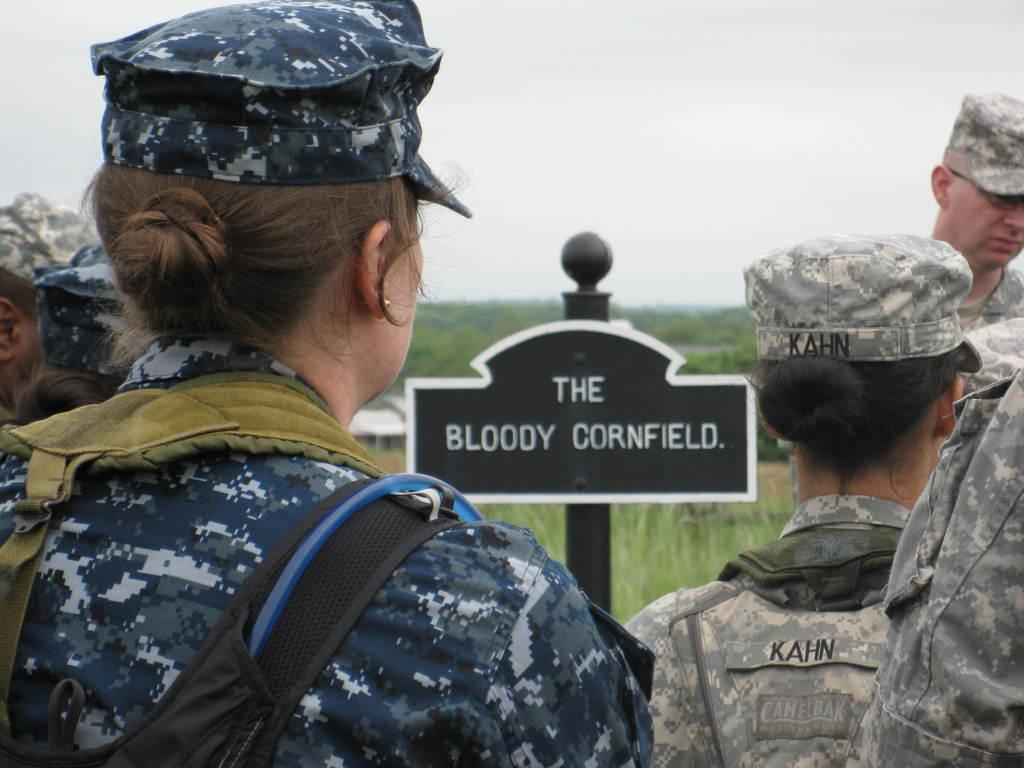Who are the people in the image? There are military officers in the image. What is on the board that is visible in the image? There is a board with text in the image. What can be seen in the background of the image? The sky is visible in the image. How would you describe the clarity of the background in the image? The background of the image is blurred. How does the smoke affect the view in the image? There is no smoke present in the image, so it does not affect the view. 